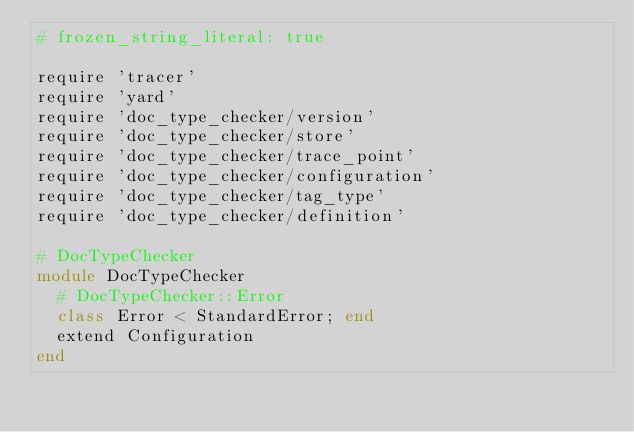<code> <loc_0><loc_0><loc_500><loc_500><_Ruby_># frozen_string_literal: true

require 'tracer'
require 'yard'
require 'doc_type_checker/version'
require 'doc_type_checker/store'
require 'doc_type_checker/trace_point'
require 'doc_type_checker/configuration'
require 'doc_type_checker/tag_type'
require 'doc_type_checker/definition'

# DocTypeChecker
module DocTypeChecker
  # DocTypeChecker::Error
  class Error < StandardError; end
  extend Configuration
end
</code> 